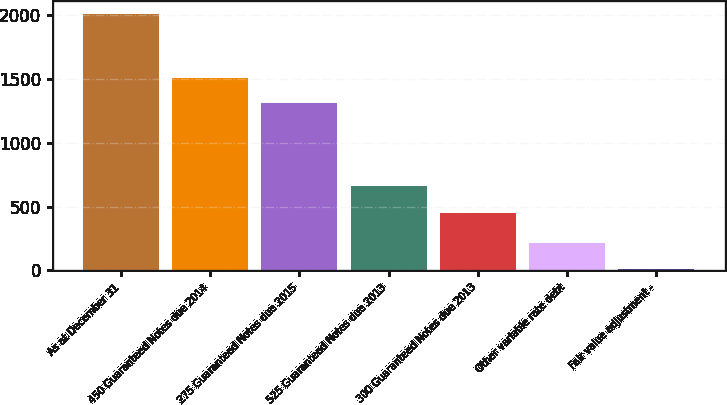Convert chart. <chart><loc_0><loc_0><loc_500><loc_500><bar_chart><fcel>As at December 31<fcel>450 Guaranteed Notes due 2014<fcel>275 Guaranteed Notes due 2015<fcel>525 Guaranteed Notes due 2013<fcel>300 Guaranteed Notes due 2013<fcel>Other variable rate debt<fcel>Fair value adjustment -<nl><fcel>2010<fcel>1509.7<fcel>1310<fcel>659<fcel>450<fcel>212.7<fcel>13<nl></chart> 